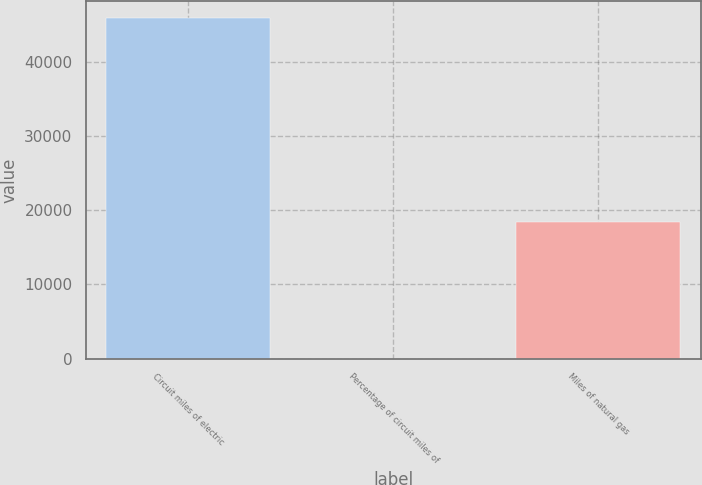Convert chart to OTSL. <chart><loc_0><loc_0><loc_500><loc_500><bar_chart><fcel>Circuit miles of electric<fcel>Percentage of circuit miles of<fcel>Miles of natural gas<nl><fcel>45878<fcel>16<fcel>18417<nl></chart> 